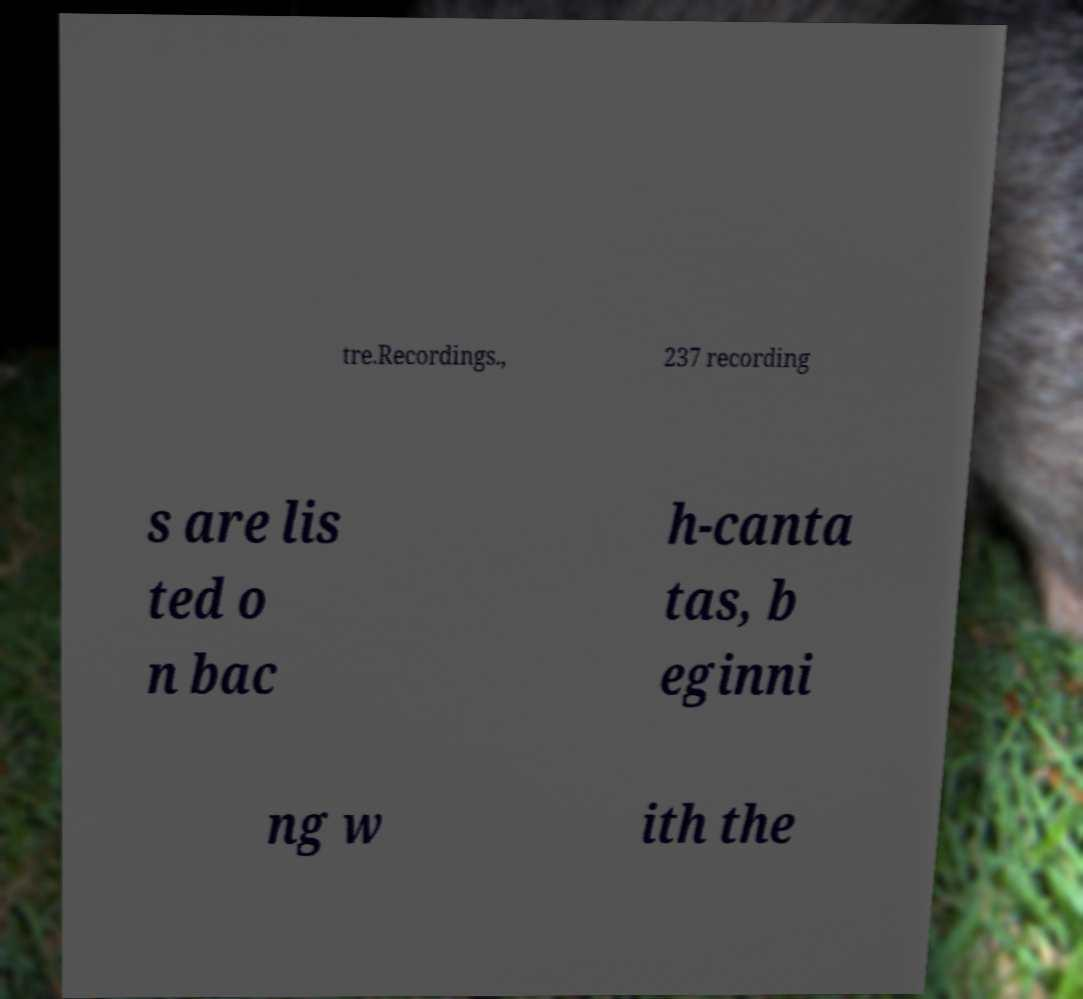Please identify and transcribe the text found in this image. tre.Recordings., 237 recording s are lis ted o n bac h-canta tas, b eginni ng w ith the 